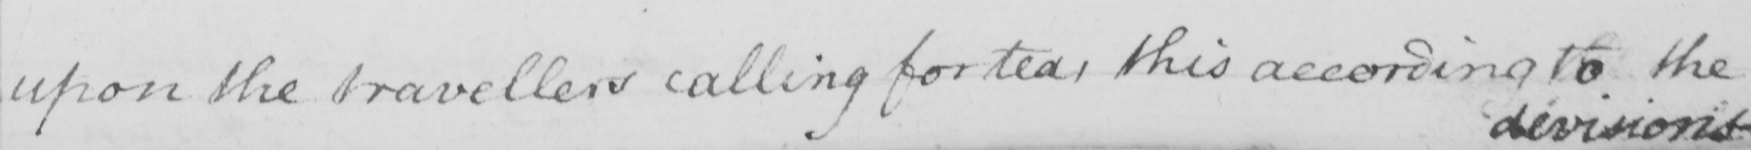Please transcribe the handwritten text in this image. upon the travellers calling for tea , this according to the 